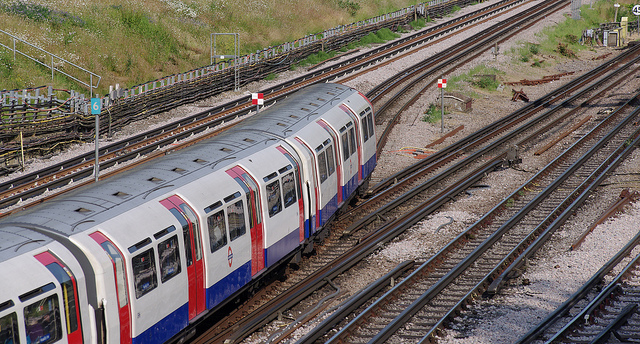Identify and read out the text in this image. 6 